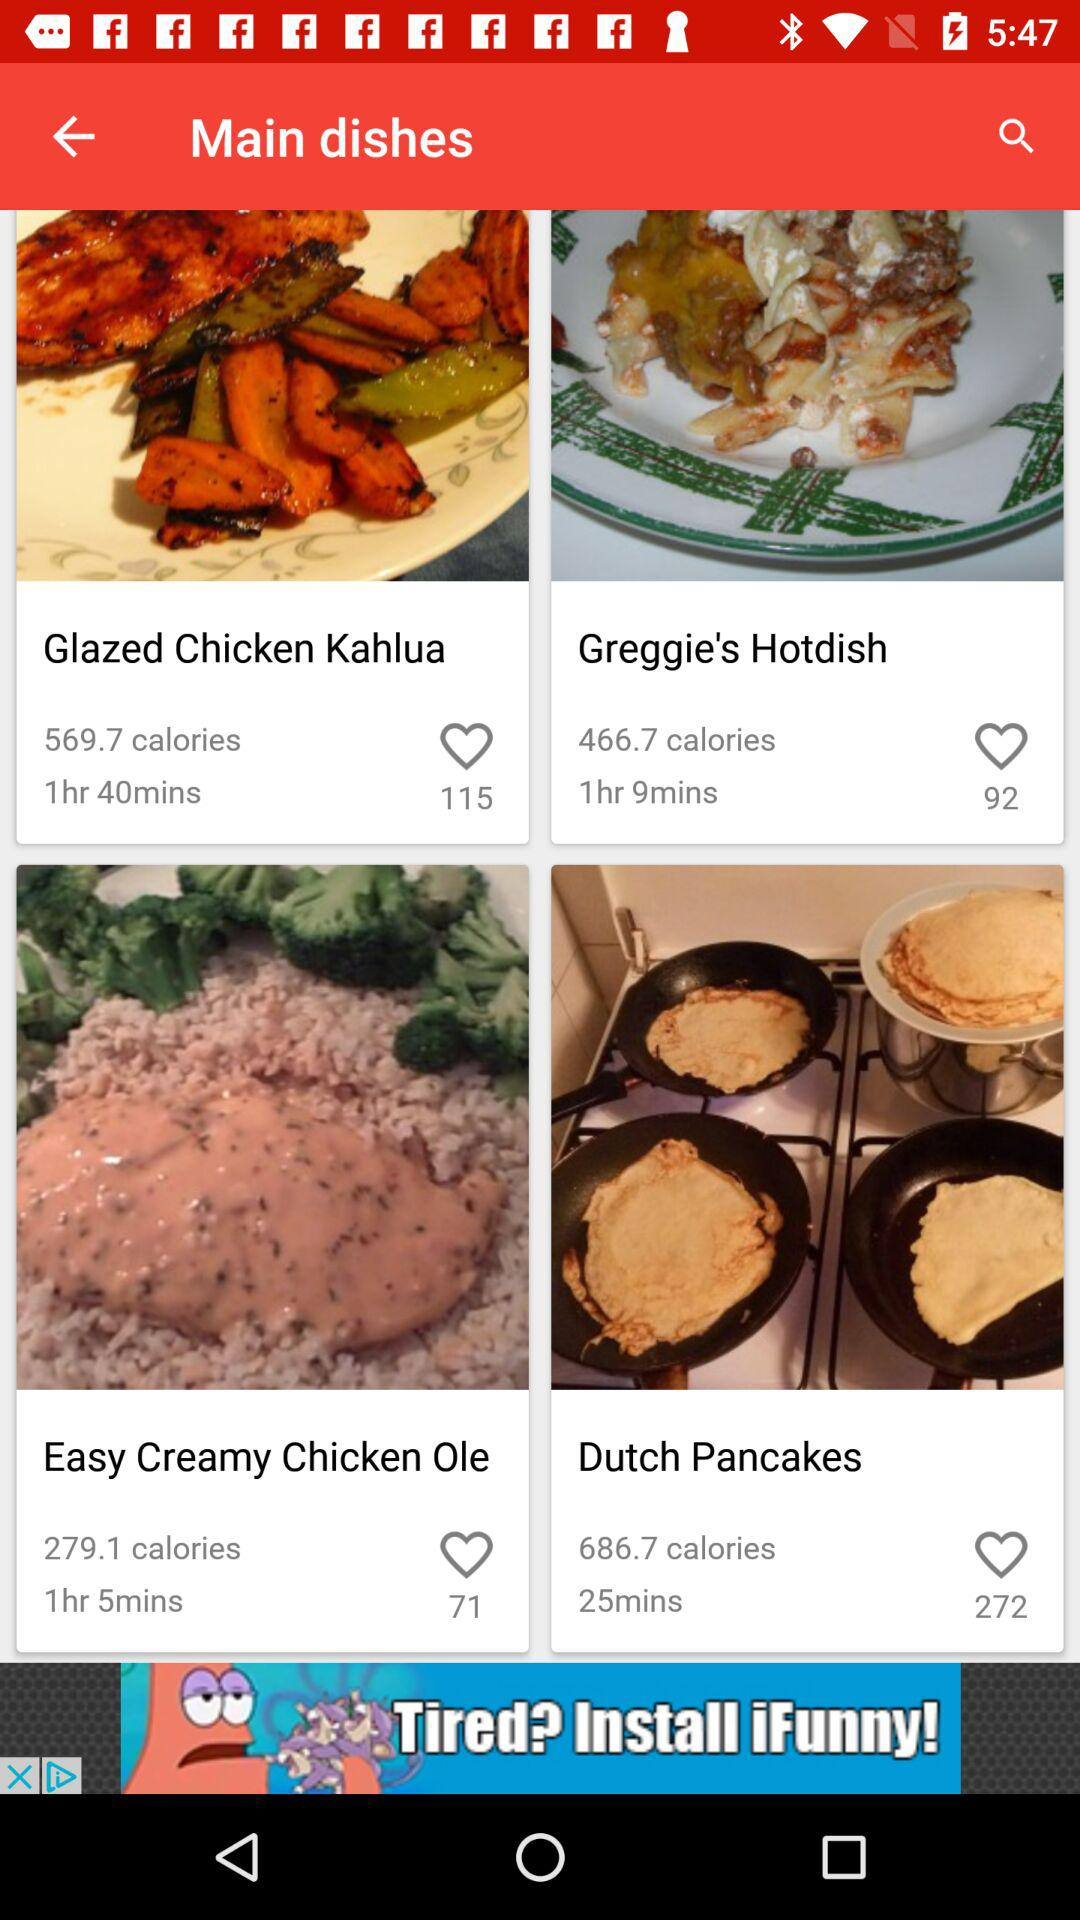What is the preparation time required to make "Easy Creamy Chicken Ole"? The preparation time is 1 hour 5 minutes. 